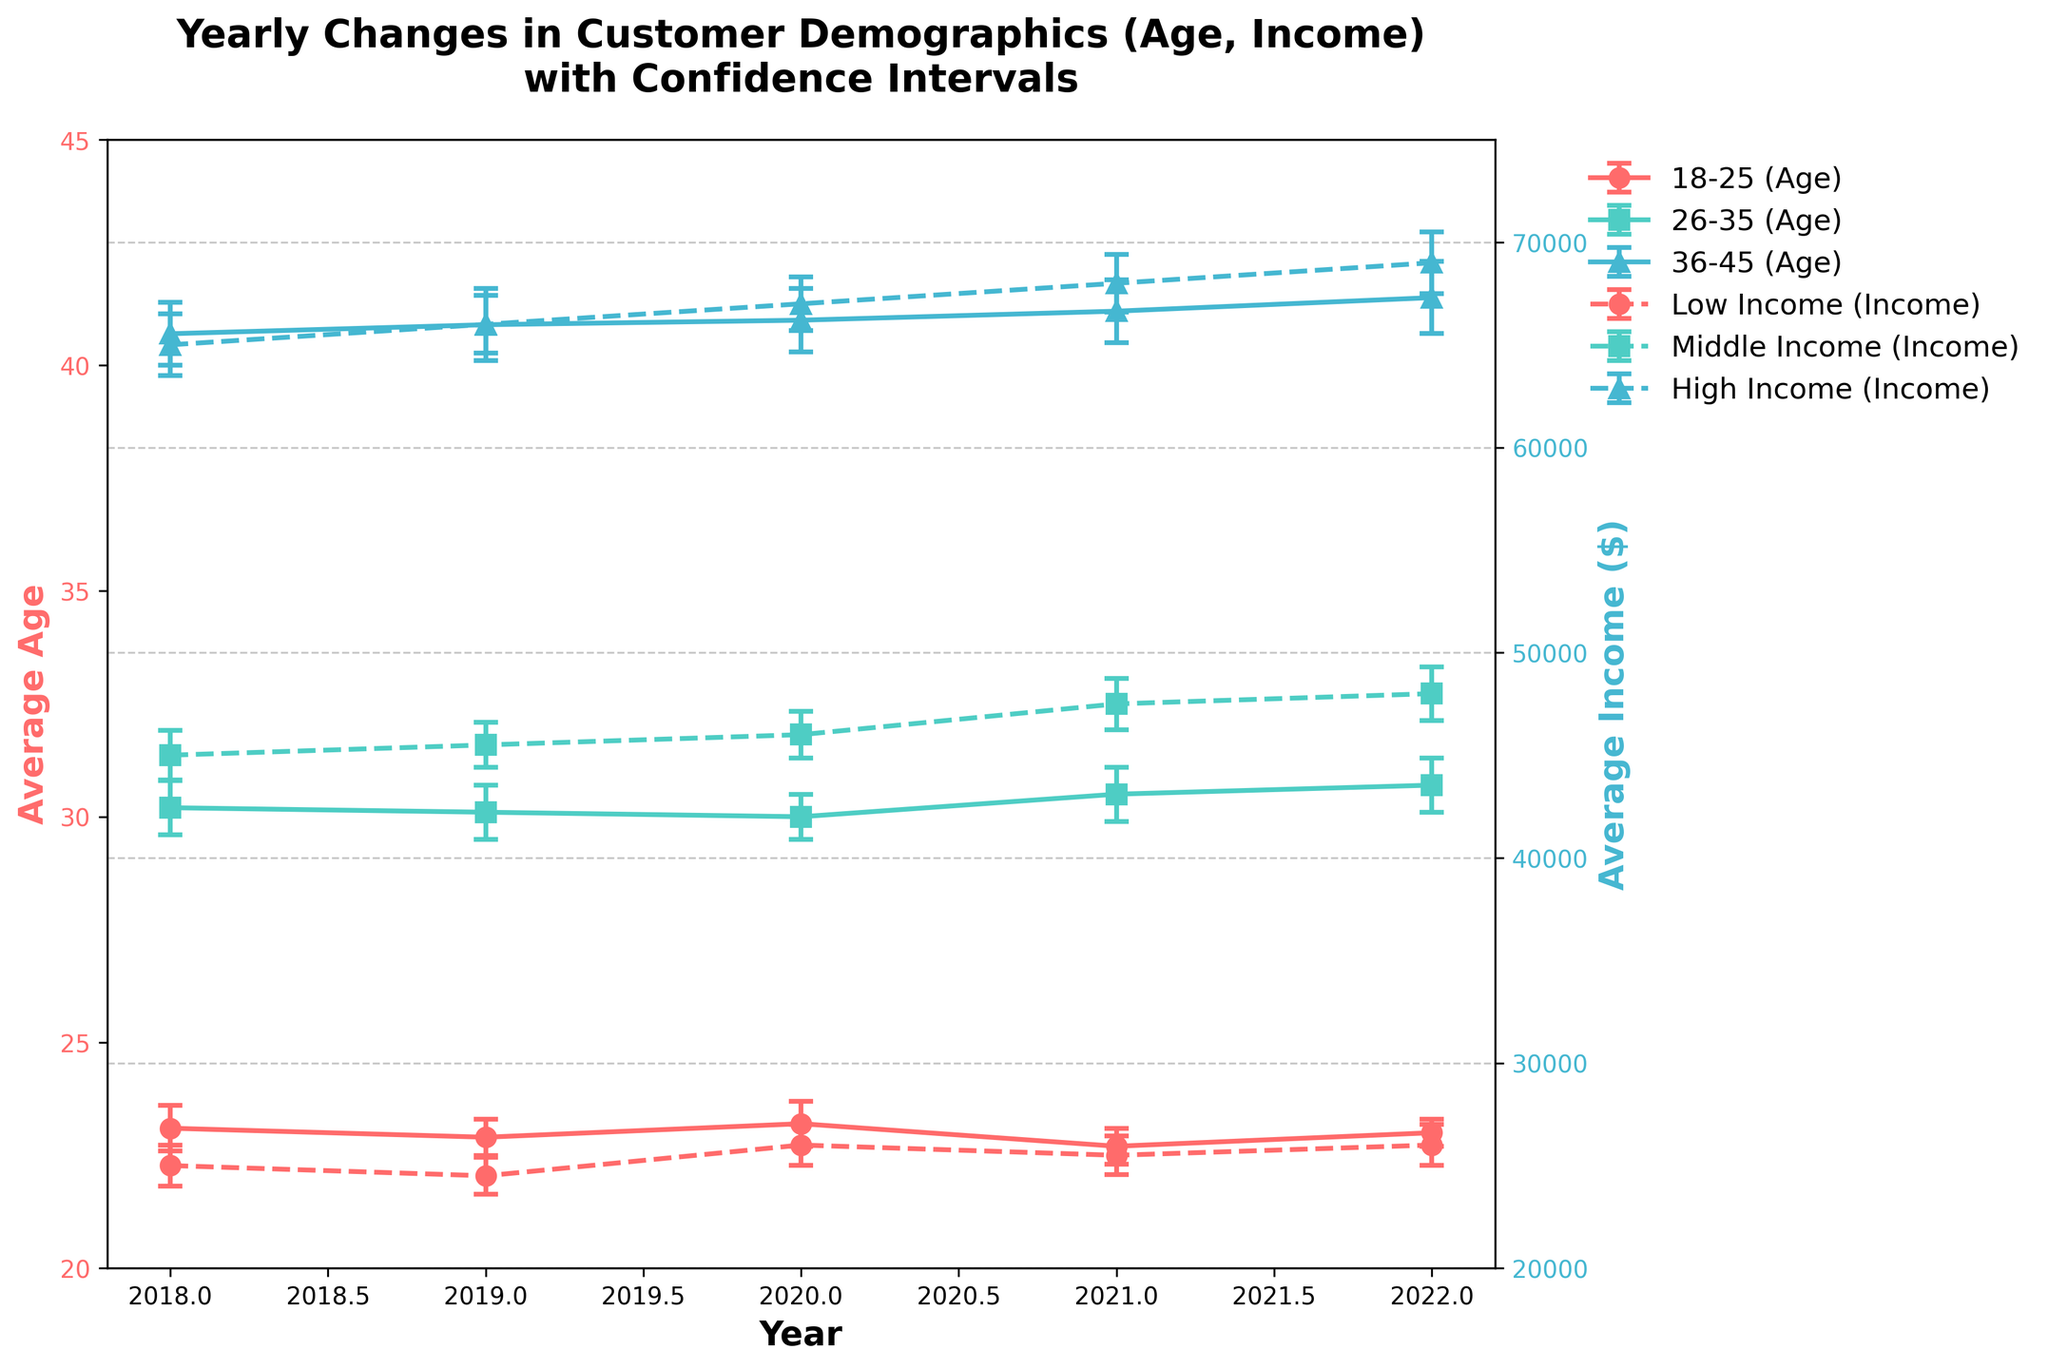What's the title of the plot? The title of the plot is usually displayed at the top center of the figure, often in bold for better visibility.
Answer: Yearly Changes in Customer Demographics (Age, Income) with Confidence Intervals Which age group has the lowest average age in 2021? To determine this, inspect the lines related to average age values in 2021, and identify the lowest point.
Answer: 18-25 What is the average income for the middle-income group in 2022? Look at the data points along the line designated for the middle-income group, specifically for the year 2022, typically displayed near the end of the timeline.
Answer: 48000 How has the average age in the 26-35 age group changed from 2018 to 2022? Compare the average age at the start (2018) and end (2022) of the plot for the 26-35 age group. Subtract the value in 2018 from the value in 2022.
Answer: Increased by 0.5 Which income group saw the highest increase in average income from 2018 to 2022? Examine each income group's data points from 2018 to 2022 and calculate the difference in average income values. The group with the largest positive difference has the highest increase.
Answer: High Income Do the error bars for the average age of the 36-45 age group in 2020 and 2021 overlap? To verify overlap, check if the error bars (shown as lines extending above and below the point) for 2020 and 2021 intersect or touch each other.
Answer: Yes Which year shows the lowest average income for the low-income group? Inspect the values plotted for the low-income group across different years; identify the lowest point in the plot.
Answer: 2019 What was the average age for the 18-25 group in 2020, and what does this suggest when compared to 2018? Locate the point for 18-25 age group in 2020 and note its value, then compare it to the corresponding point in 2018. Calculate the difference if needed.
Answer: 23.2; It's slightly higher than in 2018, suggesting an increase Is there a year where the average age of the 36-45 age group decreased compared to the previous year? By analyzing the points year by year for the 36-45 group, note any point lower than its preceding point.
Answer: No How does the change in average age for 18-25 compare to 26-35 from 2018 to 2022? Calculate the difference in average age for both 18-25 and 26-35 from 2018 to 2022. Compare these two differences.
Answer: 18-25 changed by -0.1 while 26-35 changed by 0.5 